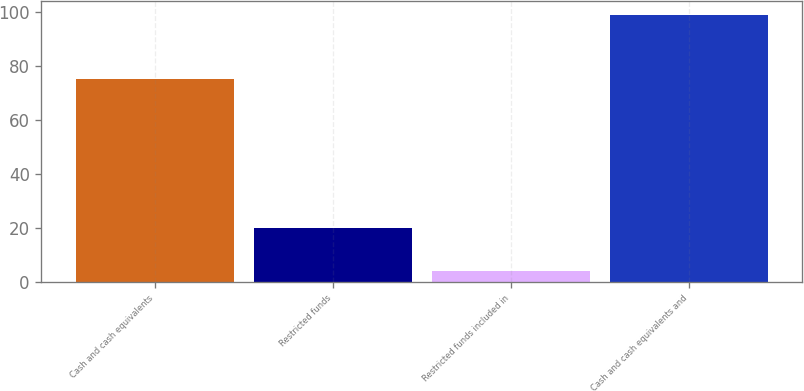Convert chart to OTSL. <chart><loc_0><loc_0><loc_500><loc_500><bar_chart><fcel>Cash and cash equivalents<fcel>Restricted funds<fcel>Restricted funds included in<fcel>Cash and cash equivalents and<nl><fcel>75<fcel>20<fcel>4<fcel>99<nl></chart> 